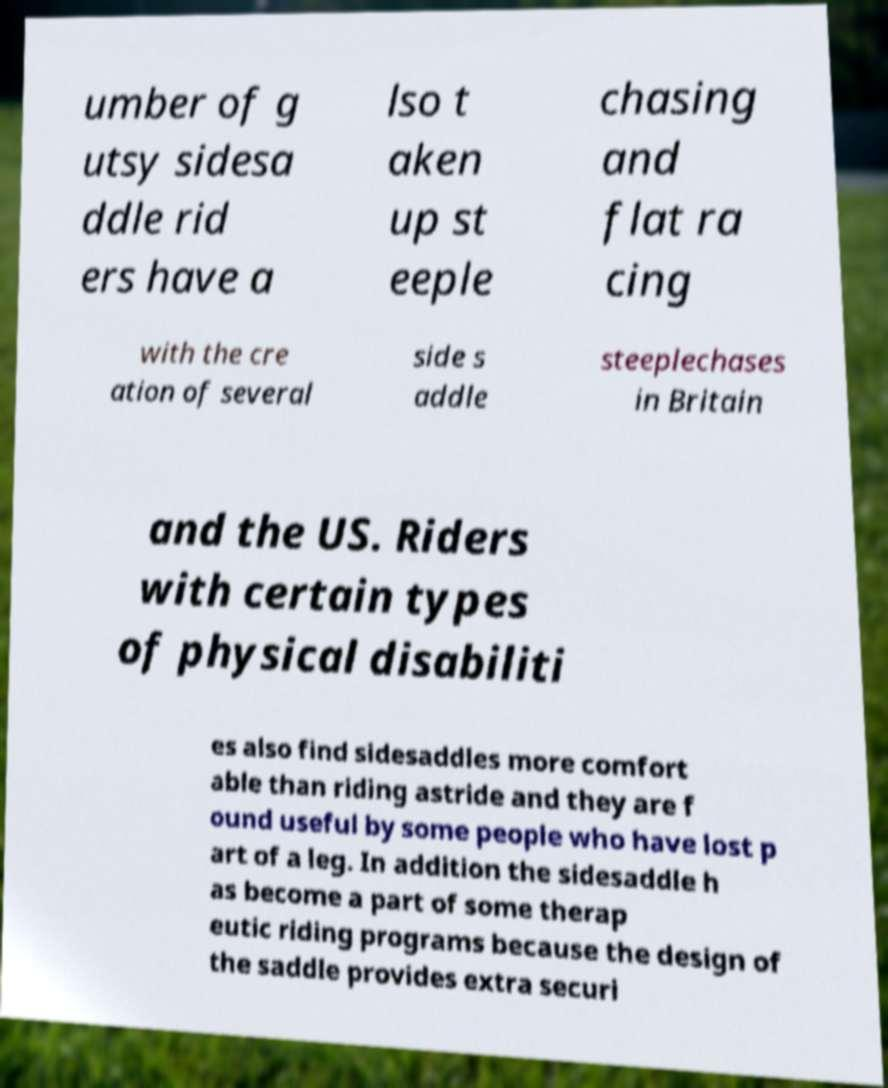What messages or text are displayed in this image? I need them in a readable, typed format. umber of g utsy sidesa ddle rid ers have a lso t aken up st eeple chasing and flat ra cing with the cre ation of several side s addle steeplechases in Britain and the US. Riders with certain types of physical disabiliti es also find sidesaddles more comfort able than riding astride and they are f ound useful by some people who have lost p art of a leg. In addition the sidesaddle h as become a part of some therap eutic riding programs because the design of the saddle provides extra securi 